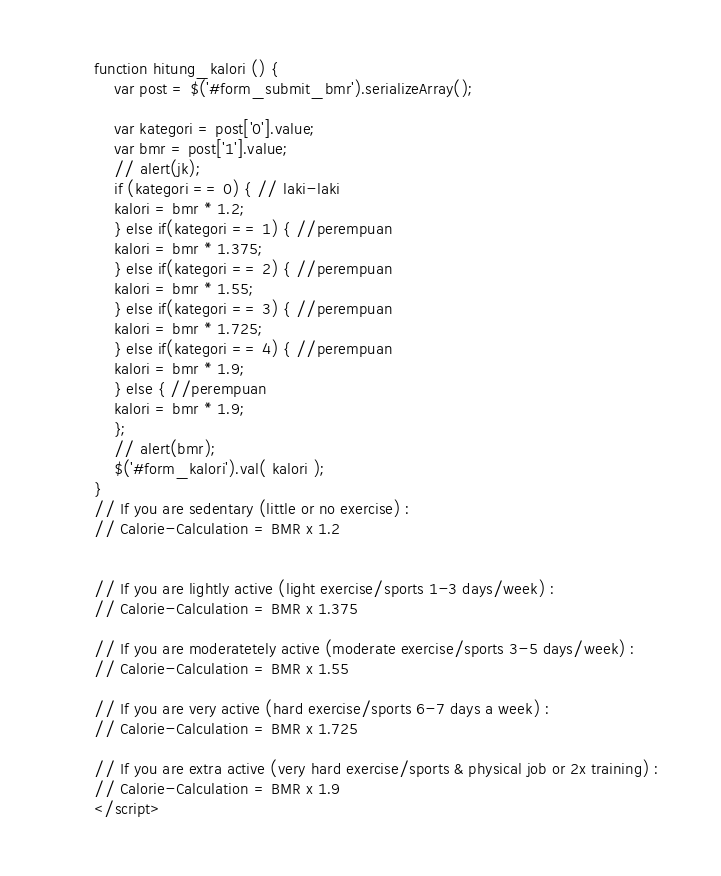Convert code to text. <code><loc_0><loc_0><loc_500><loc_500><_PHP_>
function hitung_kalori () {
	var post = $('#form_submit_bmr').serializeArray();

	var kategori = post['0'].value;
	var bmr = post['1'].value;
	// alert(jk);
	if (kategori == 0) { // laki-laki
	kalori = bmr * 1.2;
	} else if(kategori == 1) { //perempuan
	kalori = bmr * 1.375;
	} else if(kategori == 2) { //perempuan
	kalori = bmr * 1.55;
	} else if(kategori == 3) { //perempuan
	kalori = bmr * 1.725;
	} else if(kategori == 4) { //perempuan
	kalori = bmr * 1.9;
	} else { //perempuan
	kalori = bmr * 1.9;
	};
	// alert(bmr);
	$('#form_kalori').val( kalori );
}
// If you are sedentary (little or no exercise) : 
// Calorie-Calculation = BMR x 1.2


// If you are lightly active (light exercise/sports 1-3 days/week) : 
// Calorie-Calculation = BMR x 1.375

// If you are moderatetely active (moderate exercise/sports 3-5 days/week) : 
// Calorie-Calculation = BMR x 1.55

// If you are very active (hard exercise/sports 6-7 days a week) : 
// Calorie-Calculation = BMR x 1.725

// If you are extra active (very hard exercise/sports & physical job or 2x training) : 
// Calorie-Calculation = BMR x 1.9
</script></code> 